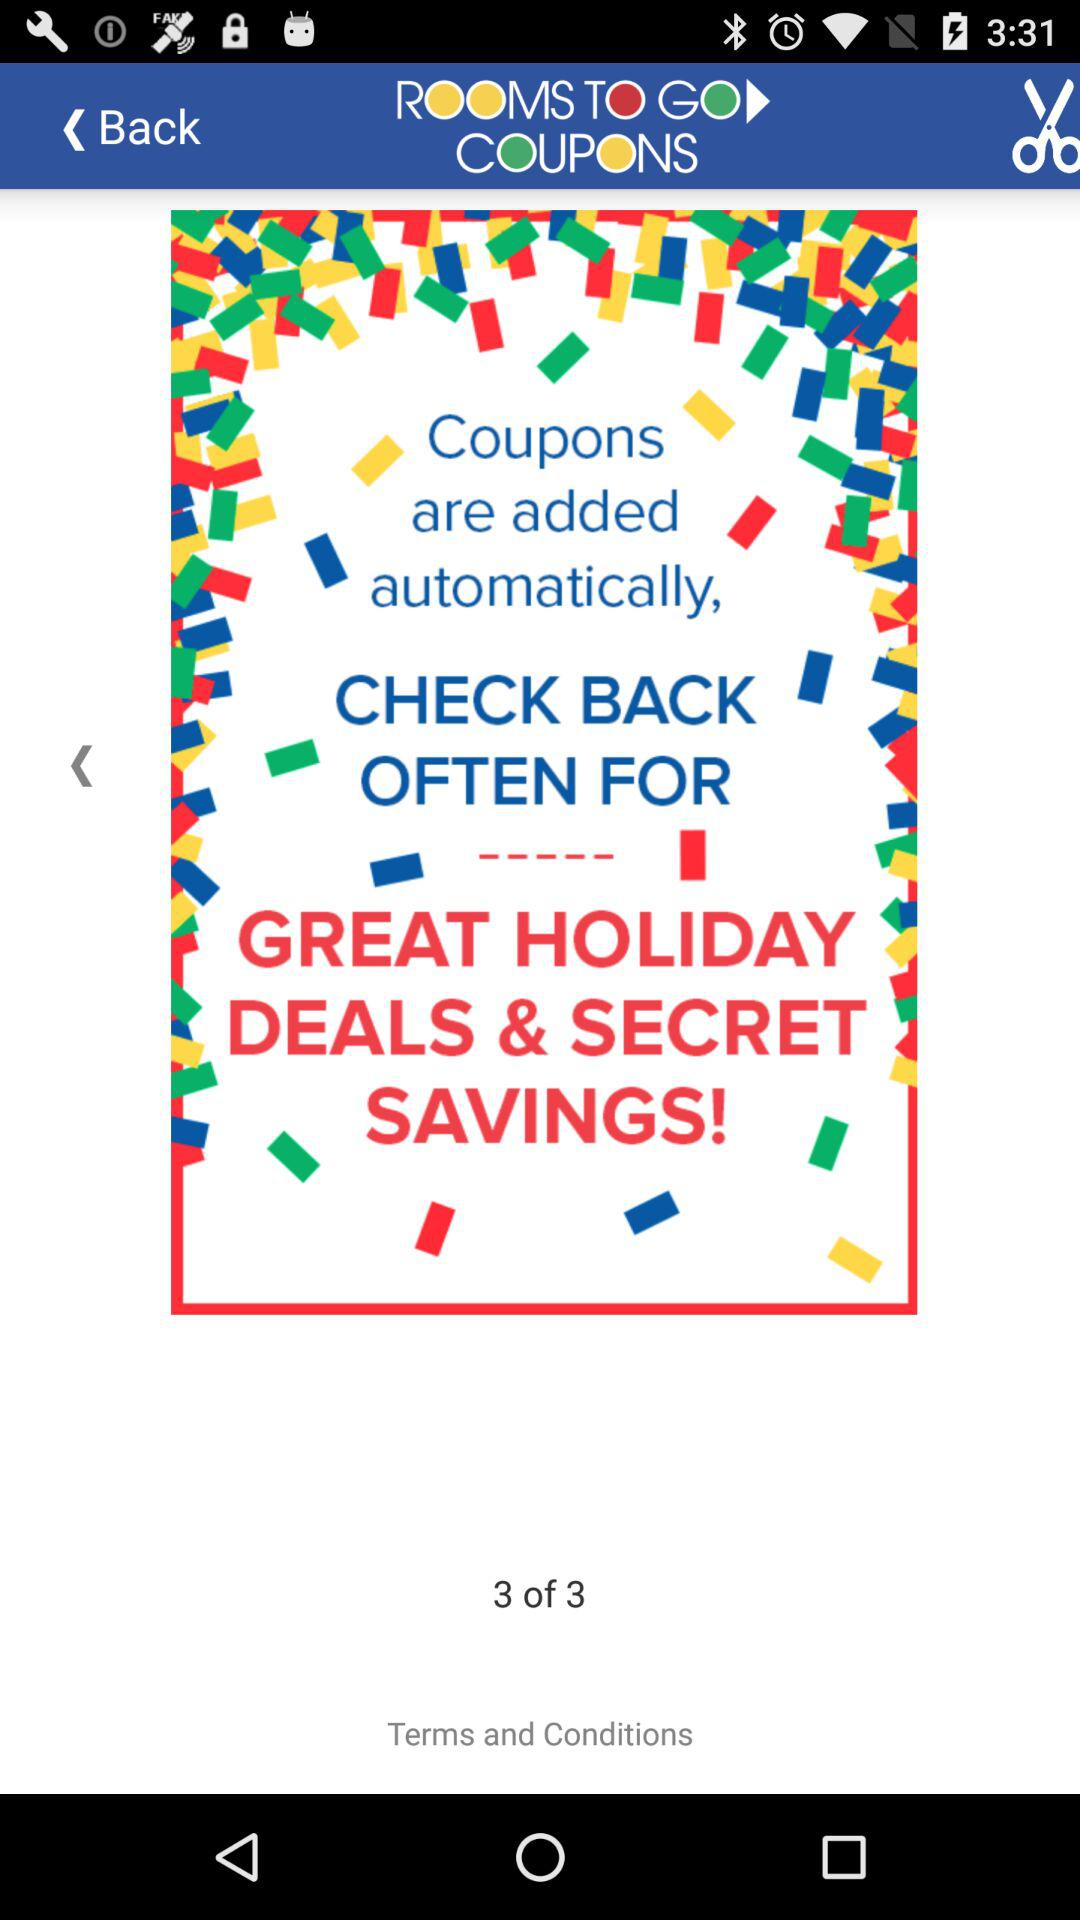What are the benefits of coupons? The benefits are great holiday deals and secret savings. 